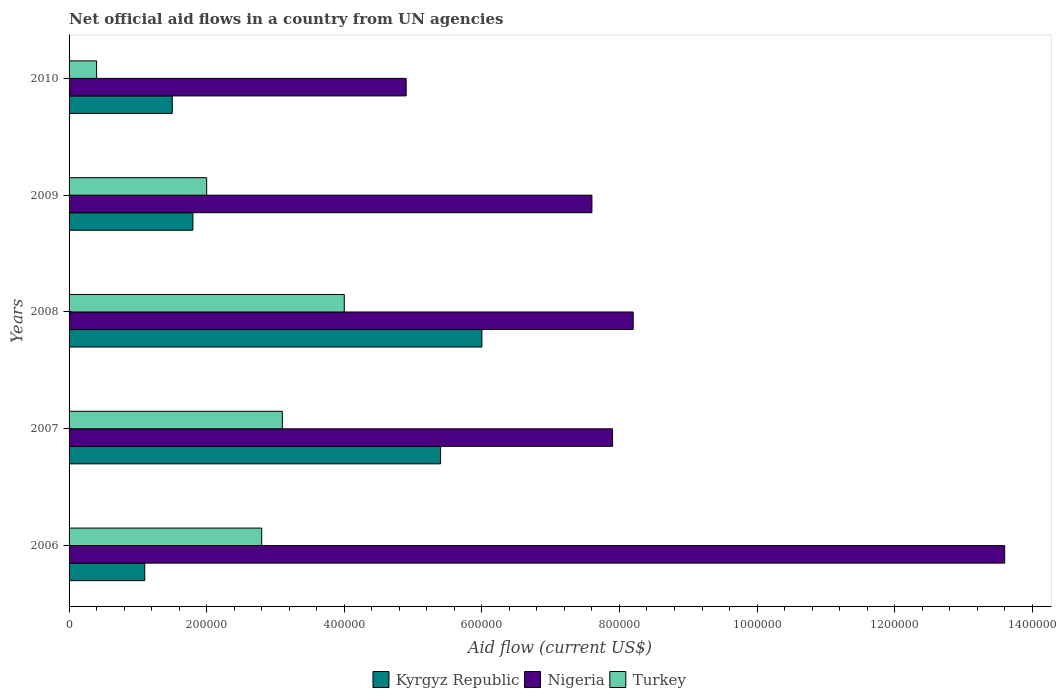How many different coloured bars are there?
Provide a short and direct response. 3. Are the number of bars on each tick of the Y-axis equal?
Your answer should be compact. Yes. What is the label of the 2nd group of bars from the top?
Give a very brief answer. 2009. Across all years, what is the maximum net official aid flow in Turkey?
Provide a short and direct response. 4.00e+05. Across all years, what is the minimum net official aid flow in Kyrgyz Republic?
Offer a terse response. 1.10e+05. In which year was the net official aid flow in Kyrgyz Republic minimum?
Offer a very short reply. 2006. What is the total net official aid flow in Nigeria in the graph?
Your answer should be very brief. 4.22e+06. What is the difference between the net official aid flow in Kyrgyz Republic in 2008 and that in 2009?
Provide a succinct answer. 4.20e+05. What is the average net official aid flow in Kyrgyz Republic per year?
Ensure brevity in your answer.  3.16e+05. In how many years, is the net official aid flow in Turkey greater than 760000 US$?
Your answer should be very brief. 0. What is the ratio of the net official aid flow in Kyrgyz Republic in 2006 to that in 2010?
Provide a succinct answer. 0.73. Is the net official aid flow in Nigeria in 2007 less than that in 2008?
Your answer should be compact. Yes. What is the difference between the highest and the lowest net official aid flow in Nigeria?
Give a very brief answer. 8.70e+05. What does the 3rd bar from the top in 2009 represents?
Keep it short and to the point. Kyrgyz Republic. What does the 1st bar from the bottom in 2010 represents?
Make the answer very short. Kyrgyz Republic. How many bars are there?
Keep it short and to the point. 15. Are all the bars in the graph horizontal?
Offer a very short reply. Yes. How many years are there in the graph?
Ensure brevity in your answer.  5. What is the difference between two consecutive major ticks on the X-axis?
Offer a very short reply. 2.00e+05. Are the values on the major ticks of X-axis written in scientific E-notation?
Provide a short and direct response. No. Does the graph contain grids?
Your answer should be compact. No. How many legend labels are there?
Offer a very short reply. 3. What is the title of the graph?
Your response must be concise. Net official aid flows in a country from UN agencies. Does "Norway" appear as one of the legend labels in the graph?
Give a very brief answer. No. What is the Aid flow (current US$) of Nigeria in 2006?
Ensure brevity in your answer.  1.36e+06. What is the Aid flow (current US$) in Turkey in 2006?
Your answer should be very brief. 2.80e+05. What is the Aid flow (current US$) in Kyrgyz Republic in 2007?
Offer a very short reply. 5.40e+05. What is the Aid flow (current US$) of Nigeria in 2007?
Keep it short and to the point. 7.90e+05. What is the Aid flow (current US$) of Turkey in 2007?
Your answer should be very brief. 3.10e+05. What is the Aid flow (current US$) of Nigeria in 2008?
Give a very brief answer. 8.20e+05. What is the Aid flow (current US$) in Turkey in 2008?
Keep it short and to the point. 4.00e+05. What is the Aid flow (current US$) of Nigeria in 2009?
Make the answer very short. 7.60e+05. What is the Aid flow (current US$) of Turkey in 2009?
Provide a short and direct response. 2.00e+05. What is the Aid flow (current US$) in Kyrgyz Republic in 2010?
Ensure brevity in your answer.  1.50e+05. What is the Aid flow (current US$) of Turkey in 2010?
Your answer should be very brief. 4.00e+04. Across all years, what is the maximum Aid flow (current US$) in Nigeria?
Provide a succinct answer. 1.36e+06. Across all years, what is the minimum Aid flow (current US$) in Turkey?
Offer a very short reply. 4.00e+04. What is the total Aid flow (current US$) in Kyrgyz Republic in the graph?
Make the answer very short. 1.58e+06. What is the total Aid flow (current US$) of Nigeria in the graph?
Offer a terse response. 4.22e+06. What is the total Aid flow (current US$) in Turkey in the graph?
Offer a terse response. 1.23e+06. What is the difference between the Aid flow (current US$) of Kyrgyz Republic in 2006 and that in 2007?
Your answer should be compact. -4.30e+05. What is the difference between the Aid flow (current US$) in Nigeria in 2006 and that in 2007?
Your response must be concise. 5.70e+05. What is the difference between the Aid flow (current US$) in Turkey in 2006 and that in 2007?
Give a very brief answer. -3.00e+04. What is the difference between the Aid flow (current US$) of Kyrgyz Republic in 2006 and that in 2008?
Offer a terse response. -4.90e+05. What is the difference between the Aid flow (current US$) of Nigeria in 2006 and that in 2008?
Ensure brevity in your answer.  5.40e+05. What is the difference between the Aid flow (current US$) of Kyrgyz Republic in 2006 and that in 2009?
Provide a succinct answer. -7.00e+04. What is the difference between the Aid flow (current US$) of Nigeria in 2006 and that in 2009?
Your answer should be compact. 6.00e+05. What is the difference between the Aid flow (current US$) of Turkey in 2006 and that in 2009?
Offer a terse response. 8.00e+04. What is the difference between the Aid flow (current US$) in Nigeria in 2006 and that in 2010?
Your answer should be compact. 8.70e+05. What is the difference between the Aid flow (current US$) in Turkey in 2006 and that in 2010?
Ensure brevity in your answer.  2.40e+05. What is the difference between the Aid flow (current US$) in Turkey in 2007 and that in 2008?
Your answer should be compact. -9.00e+04. What is the difference between the Aid flow (current US$) of Kyrgyz Republic in 2007 and that in 2010?
Your answer should be very brief. 3.90e+05. What is the difference between the Aid flow (current US$) of Nigeria in 2008 and that in 2009?
Give a very brief answer. 6.00e+04. What is the difference between the Aid flow (current US$) of Turkey in 2008 and that in 2009?
Your response must be concise. 2.00e+05. What is the difference between the Aid flow (current US$) in Nigeria in 2008 and that in 2010?
Provide a short and direct response. 3.30e+05. What is the difference between the Aid flow (current US$) of Kyrgyz Republic in 2009 and that in 2010?
Give a very brief answer. 3.00e+04. What is the difference between the Aid flow (current US$) in Kyrgyz Republic in 2006 and the Aid flow (current US$) in Nigeria in 2007?
Your response must be concise. -6.80e+05. What is the difference between the Aid flow (current US$) of Nigeria in 2006 and the Aid flow (current US$) of Turkey in 2007?
Offer a very short reply. 1.05e+06. What is the difference between the Aid flow (current US$) in Kyrgyz Republic in 2006 and the Aid flow (current US$) in Nigeria in 2008?
Provide a succinct answer. -7.10e+05. What is the difference between the Aid flow (current US$) of Kyrgyz Republic in 2006 and the Aid flow (current US$) of Turkey in 2008?
Your response must be concise. -2.90e+05. What is the difference between the Aid flow (current US$) of Nigeria in 2006 and the Aid flow (current US$) of Turkey in 2008?
Provide a short and direct response. 9.60e+05. What is the difference between the Aid flow (current US$) of Kyrgyz Republic in 2006 and the Aid flow (current US$) of Nigeria in 2009?
Ensure brevity in your answer.  -6.50e+05. What is the difference between the Aid flow (current US$) in Nigeria in 2006 and the Aid flow (current US$) in Turkey in 2009?
Offer a terse response. 1.16e+06. What is the difference between the Aid flow (current US$) of Kyrgyz Republic in 2006 and the Aid flow (current US$) of Nigeria in 2010?
Ensure brevity in your answer.  -3.80e+05. What is the difference between the Aid flow (current US$) in Nigeria in 2006 and the Aid flow (current US$) in Turkey in 2010?
Your response must be concise. 1.32e+06. What is the difference between the Aid flow (current US$) of Kyrgyz Republic in 2007 and the Aid flow (current US$) of Nigeria in 2008?
Provide a succinct answer. -2.80e+05. What is the difference between the Aid flow (current US$) of Kyrgyz Republic in 2007 and the Aid flow (current US$) of Turkey in 2008?
Your answer should be compact. 1.40e+05. What is the difference between the Aid flow (current US$) of Nigeria in 2007 and the Aid flow (current US$) of Turkey in 2008?
Ensure brevity in your answer.  3.90e+05. What is the difference between the Aid flow (current US$) in Kyrgyz Republic in 2007 and the Aid flow (current US$) in Nigeria in 2009?
Keep it short and to the point. -2.20e+05. What is the difference between the Aid flow (current US$) of Nigeria in 2007 and the Aid flow (current US$) of Turkey in 2009?
Offer a very short reply. 5.90e+05. What is the difference between the Aid flow (current US$) of Nigeria in 2007 and the Aid flow (current US$) of Turkey in 2010?
Make the answer very short. 7.50e+05. What is the difference between the Aid flow (current US$) in Kyrgyz Republic in 2008 and the Aid flow (current US$) in Nigeria in 2009?
Ensure brevity in your answer.  -1.60e+05. What is the difference between the Aid flow (current US$) in Nigeria in 2008 and the Aid flow (current US$) in Turkey in 2009?
Ensure brevity in your answer.  6.20e+05. What is the difference between the Aid flow (current US$) of Kyrgyz Republic in 2008 and the Aid flow (current US$) of Turkey in 2010?
Your answer should be very brief. 5.60e+05. What is the difference between the Aid flow (current US$) in Nigeria in 2008 and the Aid flow (current US$) in Turkey in 2010?
Make the answer very short. 7.80e+05. What is the difference between the Aid flow (current US$) of Kyrgyz Republic in 2009 and the Aid flow (current US$) of Nigeria in 2010?
Provide a short and direct response. -3.10e+05. What is the difference between the Aid flow (current US$) in Nigeria in 2009 and the Aid flow (current US$) in Turkey in 2010?
Your answer should be compact. 7.20e+05. What is the average Aid flow (current US$) of Kyrgyz Republic per year?
Give a very brief answer. 3.16e+05. What is the average Aid flow (current US$) of Nigeria per year?
Give a very brief answer. 8.44e+05. What is the average Aid flow (current US$) of Turkey per year?
Make the answer very short. 2.46e+05. In the year 2006, what is the difference between the Aid flow (current US$) in Kyrgyz Republic and Aid flow (current US$) in Nigeria?
Offer a very short reply. -1.25e+06. In the year 2006, what is the difference between the Aid flow (current US$) in Kyrgyz Republic and Aid flow (current US$) in Turkey?
Your answer should be compact. -1.70e+05. In the year 2006, what is the difference between the Aid flow (current US$) of Nigeria and Aid flow (current US$) of Turkey?
Your response must be concise. 1.08e+06. In the year 2007, what is the difference between the Aid flow (current US$) of Nigeria and Aid flow (current US$) of Turkey?
Your answer should be compact. 4.80e+05. In the year 2008, what is the difference between the Aid flow (current US$) of Kyrgyz Republic and Aid flow (current US$) of Nigeria?
Keep it short and to the point. -2.20e+05. In the year 2008, what is the difference between the Aid flow (current US$) of Kyrgyz Republic and Aid flow (current US$) of Turkey?
Your answer should be very brief. 2.00e+05. In the year 2008, what is the difference between the Aid flow (current US$) of Nigeria and Aid flow (current US$) of Turkey?
Provide a short and direct response. 4.20e+05. In the year 2009, what is the difference between the Aid flow (current US$) of Kyrgyz Republic and Aid flow (current US$) of Nigeria?
Your answer should be compact. -5.80e+05. In the year 2009, what is the difference between the Aid flow (current US$) of Kyrgyz Republic and Aid flow (current US$) of Turkey?
Provide a short and direct response. -2.00e+04. In the year 2009, what is the difference between the Aid flow (current US$) of Nigeria and Aid flow (current US$) of Turkey?
Offer a terse response. 5.60e+05. In the year 2010, what is the difference between the Aid flow (current US$) in Kyrgyz Republic and Aid flow (current US$) in Turkey?
Your answer should be compact. 1.10e+05. In the year 2010, what is the difference between the Aid flow (current US$) of Nigeria and Aid flow (current US$) of Turkey?
Provide a succinct answer. 4.50e+05. What is the ratio of the Aid flow (current US$) in Kyrgyz Republic in 2006 to that in 2007?
Provide a short and direct response. 0.2. What is the ratio of the Aid flow (current US$) of Nigeria in 2006 to that in 2007?
Offer a terse response. 1.72. What is the ratio of the Aid flow (current US$) of Turkey in 2006 to that in 2007?
Your answer should be very brief. 0.9. What is the ratio of the Aid flow (current US$) in Kyrgyz Republic in 2006 to that in 2008?
Ensure brevity in your answer.  0.18. What is the ratio of the Aid flow (current US$) of Nigeria in 2006 to that in 2008?
Offer a very short reply. 1.66. What is the ratio of the Aid flow (current US$) in Turkey in 2006 to that in 2008?
Your response must be concise. 0.7. What is the ratio of the Aid flow (current US$) of Kyrgyz Republic in 2006 to that in 2009?
Your response must be concise. 0.61. What is the ratio of the Aid flow (current US$) of Nigeria in 2006 to that in 2009?
Provide a short and direct response. 1.79. What is the ratio of the Aid flow (current US$) in Kyrgyz Republic in 2006 to that in 2010?
Offer a terse response. 0.73. What is the ratio of the Aid flow (current US$) of Nigeria in 2006 to that in 2010?
Your answer should be very brief. 2.78. What is the ratio of the Aid flow (current US$) in Kyrgyz Republic in 2007 to that in 2008?
Offer a terse response. 0.9. What is the ratio of the Aid flow (current US$) of Nigeria in 2007 to that in 2008?
Your answer should be compact. 0.96. What is the ratio of the Aid flow (current US$) in Turkey in 2007 to that in 2008?
Keep it short and to the point. 0.78. What is the ratio of the Aid flow (current US$) of Nigeria in 2007 to that in 2009?
Your response must be concise. 1.04. What is the ratio of the Aid flow (current US$) in Turkey in 2007 to that in 2009?
Offer a terse response. 1.55. What is the ratio of the Aid flow (current US$) in Nigeria in 2007 to that in 2010?
Give a very brief answer. 1.61. What is the ratio of the Aid flow (current US$) of Turkey in 2007 to that in 2010?
Ensure brevity in your answer.  7.75. What is the ratio of the Aid flow (current US$) of Kyrgyz Republic in 2008 to that in 2009?
Make the answer very short. 3.33. What is the ratio of the Aid flow (current US$) in Nigeria in 2008 to that in 2009?
Offer a terse response. 1.08. What is the ratio of the Aid flow (current US$) in Turkey in 2008 to that in 2009?
Give a very brief answer. 2. What is the ratio of the Aid flow (current US$) of Nigeria in 2008 to that in 2010?
Give a very brief answer. 1.67. What is the ratio of the Aid flow (current US$) in Kyrgyz Republic in 2009 to that in 2010?
Offer a terse response. 1.2. What is the ratio of the Aid flow (current US$) of Nigeria in 2009 to that in 2010?
Your answer should be compact. 1.55. What is the ratio of the Aid flow (current US$) in Turkey in 2009 to that in 2010?
Keep it short and to the point. 5. What is the difference between the highest and the second highest Aid flow (current US$) of Nigeria?
Your response must be concise. 5.40e+05. What is the difference between the highest and the lowest Aid flow (current US$) in Nigeria?
Keep it short and to the point. 8.70e+05. 